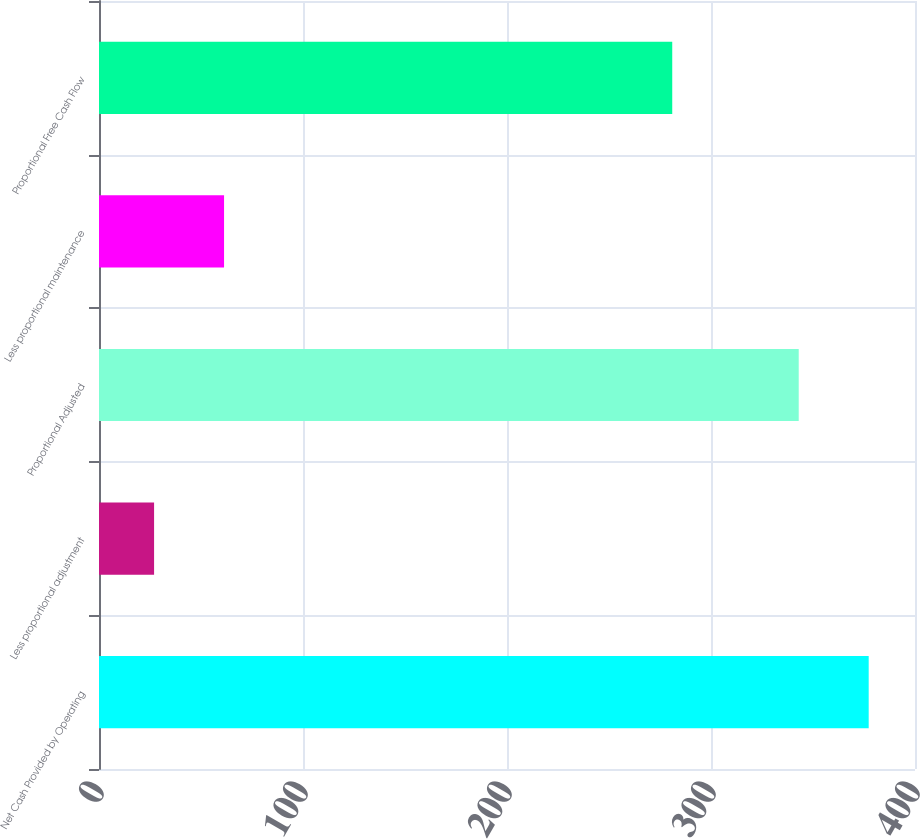Convert chart. <chart><loc_0><loc_0><loc_500><loc_500><bar_chart><fcel>Net Cash Provided by Operating<fcel>Less proportional adjustment<fcel>Proportional Adjusted<fcel>Less proportional maintenance<fcel>Proportional Free Cash Flow<nl><fcel>377.3<fcel>27<fcel>343<fcel>61.3<fcel>281<nl></chart> 